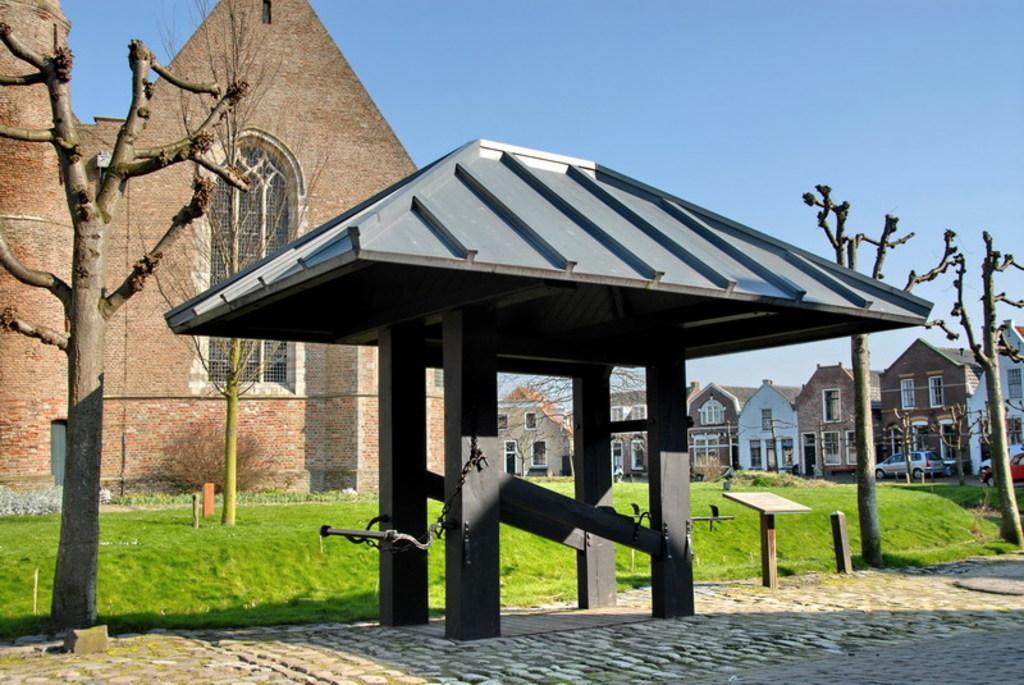How would you summarize this image in a sentence or two? There are trees and a shed in the foreground area of the image, there are houses, grassland, trees, vehicles and the sky in the background. 